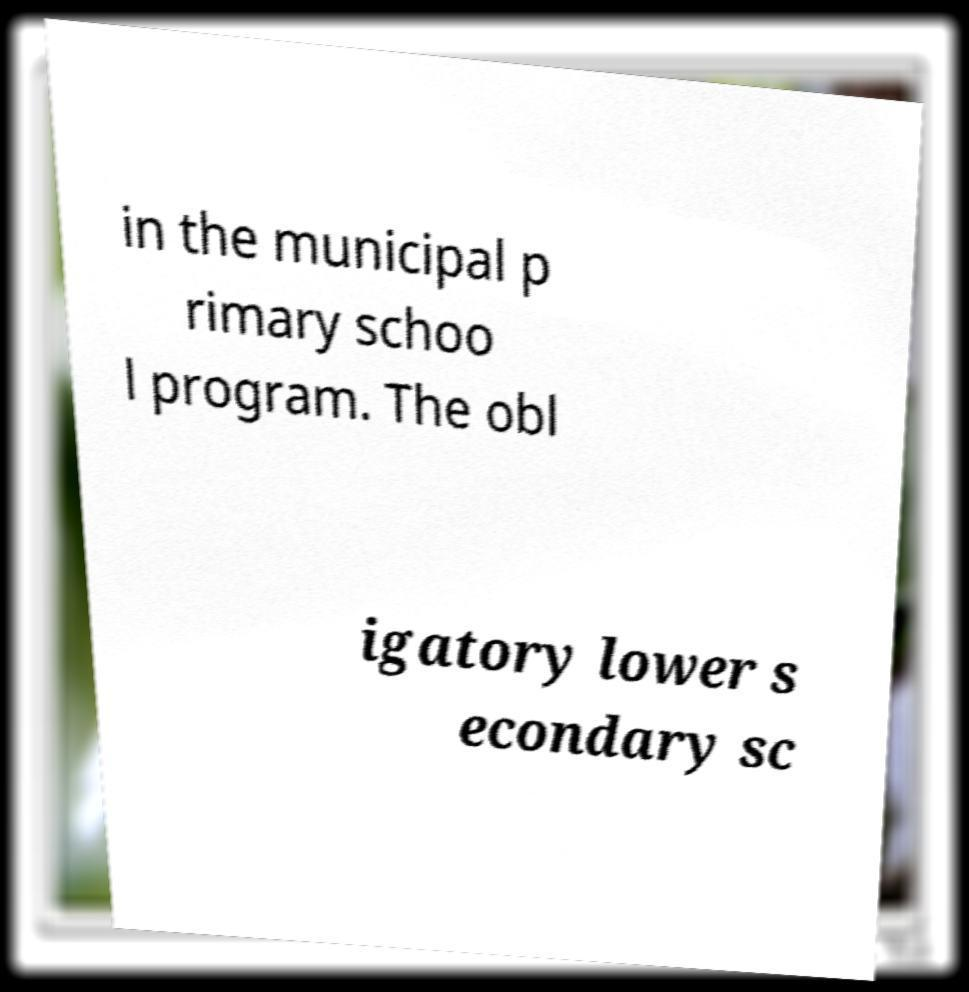For documentation purposes, I need the text within this image transcribed. Could you provide that? in the municipal p rimary schoo l program. The obl igatory lower s econdary sc 